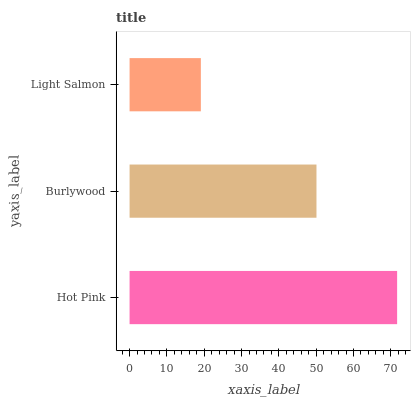Is Light Salmon the minimum?
Answer yes or no. Yes. Is Hot Pink the maximum?
Answer yes or no. Yes. Is Burlywood the minimum?
Answer yes or no. No. Is Burlywood the maximum?
Answer yes or no. No. Is Hot Pink greater than Burlywood?
Answer yes or no. Yes. Is Burlywood less than Hot Pink?
Answer yes or no. Yes. Is Burlywood greater than Hot Pink?
Answer yes or no. No. Is Hot Pink less than Burlywood?
Answer yes or no. No. Is Burlywood the high median?
Answer yes or no. Yes. Is Burlywood the low median?
Answer yes or no. Yes. Is Light Salmon the high median?
Answer yes or no. No. Is Light Salmon the low median?
Answer yes or no. No. 